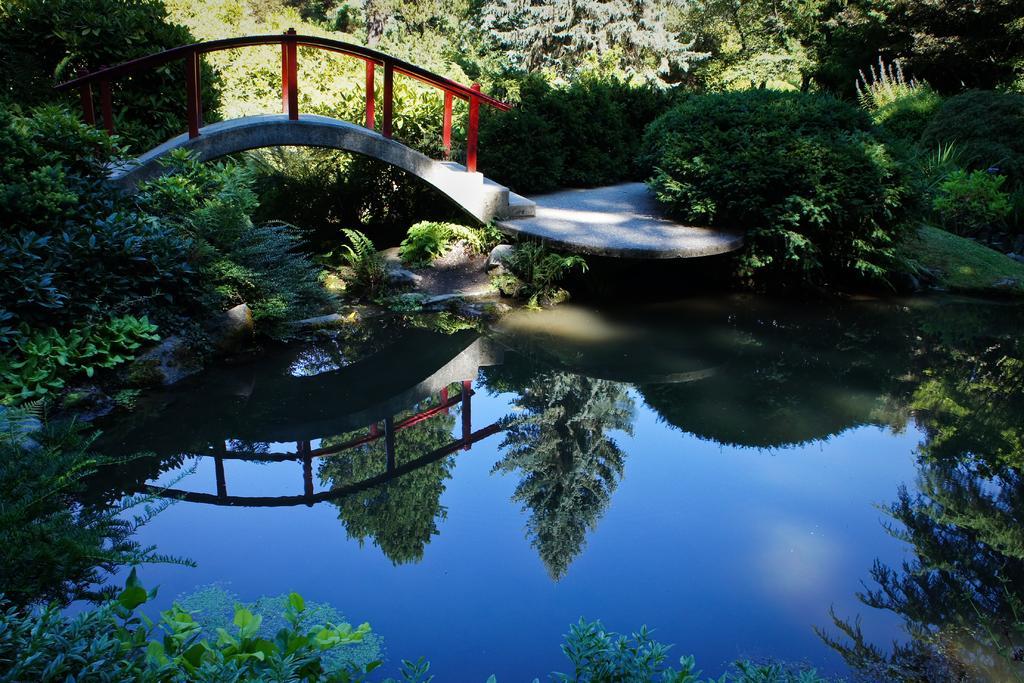How would you summarize this image in a sentence or two? In this image in the front there is water and there a leaves. In the center there are plants and there is a bridge. In the background there are trees. 